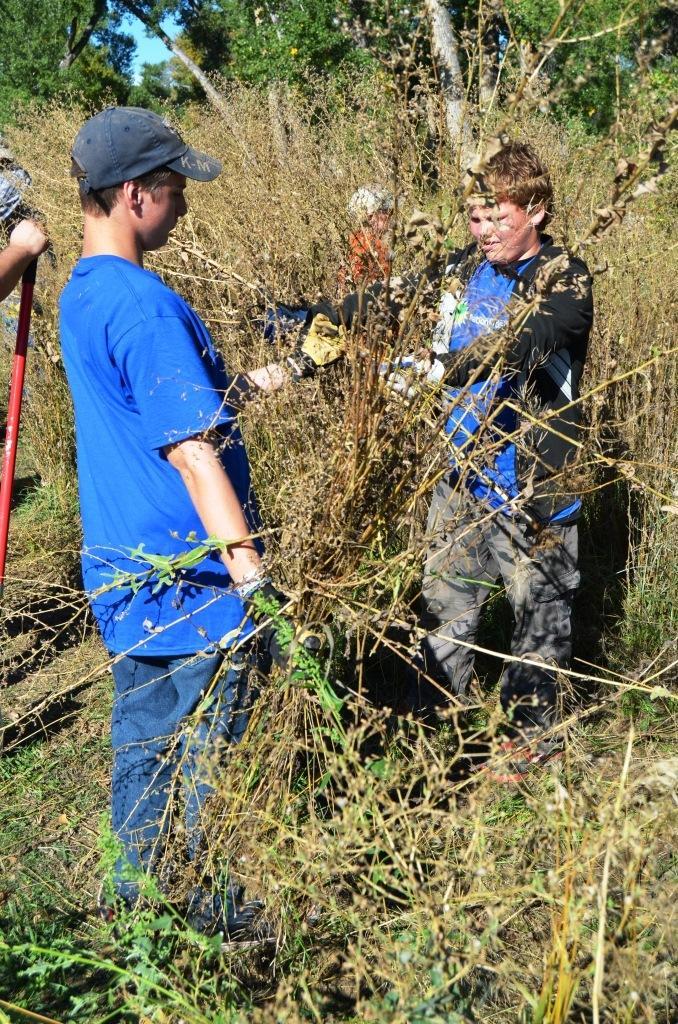Could you give a brief overview of what you see in this image? In this image we can see people standing on the ground, plants, trees and sky. 